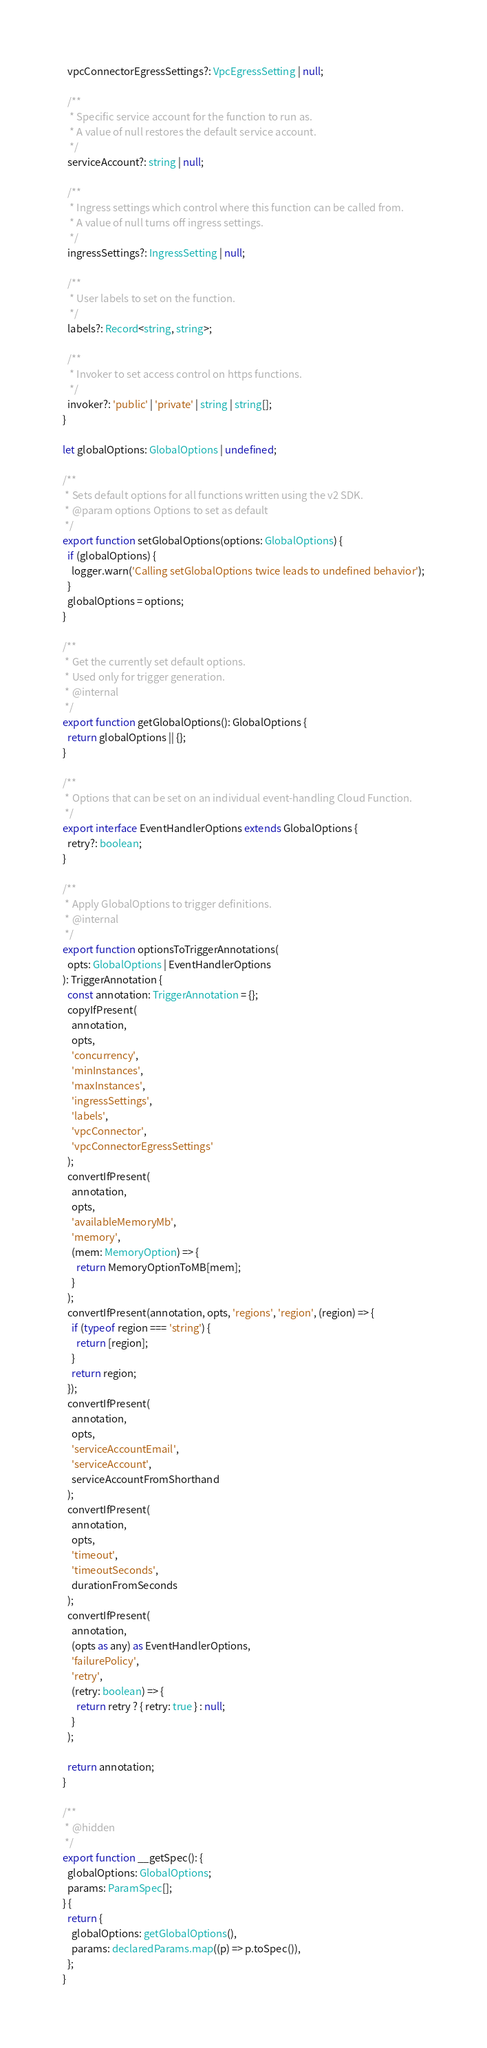Convert code to text. <code><loc_0><loc_0><loc_500><loc_500><_TypeScript_>  vpcConnectorEgressSettings?: VpcEgressSetting | null;

  /**
   * Specific service account for the function to run as.
   * A value of null restores the default service account.
   */
  serviceAccount?: string | null;

  /**
   * Ingress settings which control where this function can be called from.
   * A value of null turns off ingress settings.
   */
  ingressSettings?: IngressSetting | null;

  /**
   * User labels to set on the function.
   */
  labels?: Record<string, string>;

  /**
   * Invoker to set access control on https functions.
   */
  invoker?: 'public' | 'private' | string | string[];
}

let globalOptions: GlobalOptions | undefined;

/**
 * Sets default options for all functions written using the v2 SDK.
 * @param options Options to set as default
 */
export function setGlobalOptions(options: GlobalOptions) {
  if (globalOptions) {
    logger.warn('Calling setGlobalOptions twice leads to undefined behavior');
  }
  globalOptions = options;
}

/**
 * Get the currently set default options.
 * Used only for trigger generation.
 * @internal
 */
export function getGlobalOptions(): GlobalOptions {
  return globalOptions || {};
}

/**
 * Options that can be set on an individual event-handling Cloud Function.
 */
export interface EventHandlerOptions extends GlobalOptions {
  retry?: boolean;
}

/**
 * Apply GlobalOptions to trigger definitions.
 * @internal
 */
export function optionsToTriggerAnnotations(
  opts: GlobalOptions | EventHandlerOptions
): TriggerAnnotation {
  const annotation: TriggerAnnotation = {};
  copyIfPresent(
    annotation,
    opts,
    'concurrency',
    'minInstances',
    'maxInstances',
    'ingressSettings',
    'labels',
    'vpcConnector',
    'vpcConnectorEgressSettings'
  );
  convertIfPresent(
    annotation,
    opts,
    'availableMemoryMb',
    'memory',
    (mem: MemoryOption) => {
      return MemoryOptionToMB[mem];
    }
  );
  convertIfPresent(annotation, opts, 'regions', 'region', (region) => {
    if (typeof region === 'string') {
      return [region];
    }
    return region;
  });
  convertIfPresent(
    annotation,
    opts,
    'serviceAccountEmail',
    'serviceAccount',
    serviceAccountFromShorthand
  );
  convertIfPresent(
    annotation,
    opts,
    'timeout',
    'timeoutSeconds',
    durationFromSeconds
  );
  convertIfPresent(
    annotation,
    (opts as any) as EventHandlerOptions,
    'failurePolicy',
    'retry',
    (retry: boolean) => {
      return retry ? { retry: true } : null;
    }
  );

  return annotation;
}

/**
 * @hidden
 */
export function __getSpec(): {
  globalOptions: GlobalOptions;
  params: ParamSpec[];
} {
  return {
    globalOptions: getGlobalOptions(),
    params: declaredParams.map((p) => p.toSpec()),
  };
}
</code> 